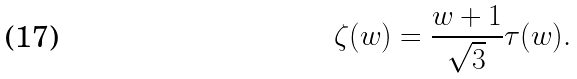Convert formula to latex. <formula><loc_0><loc_0><loc_500><loc_500>\zeta ( w ) = \frac { w + 1 } { \sqrt { 3 } } \tau ( w ) .</formula> 